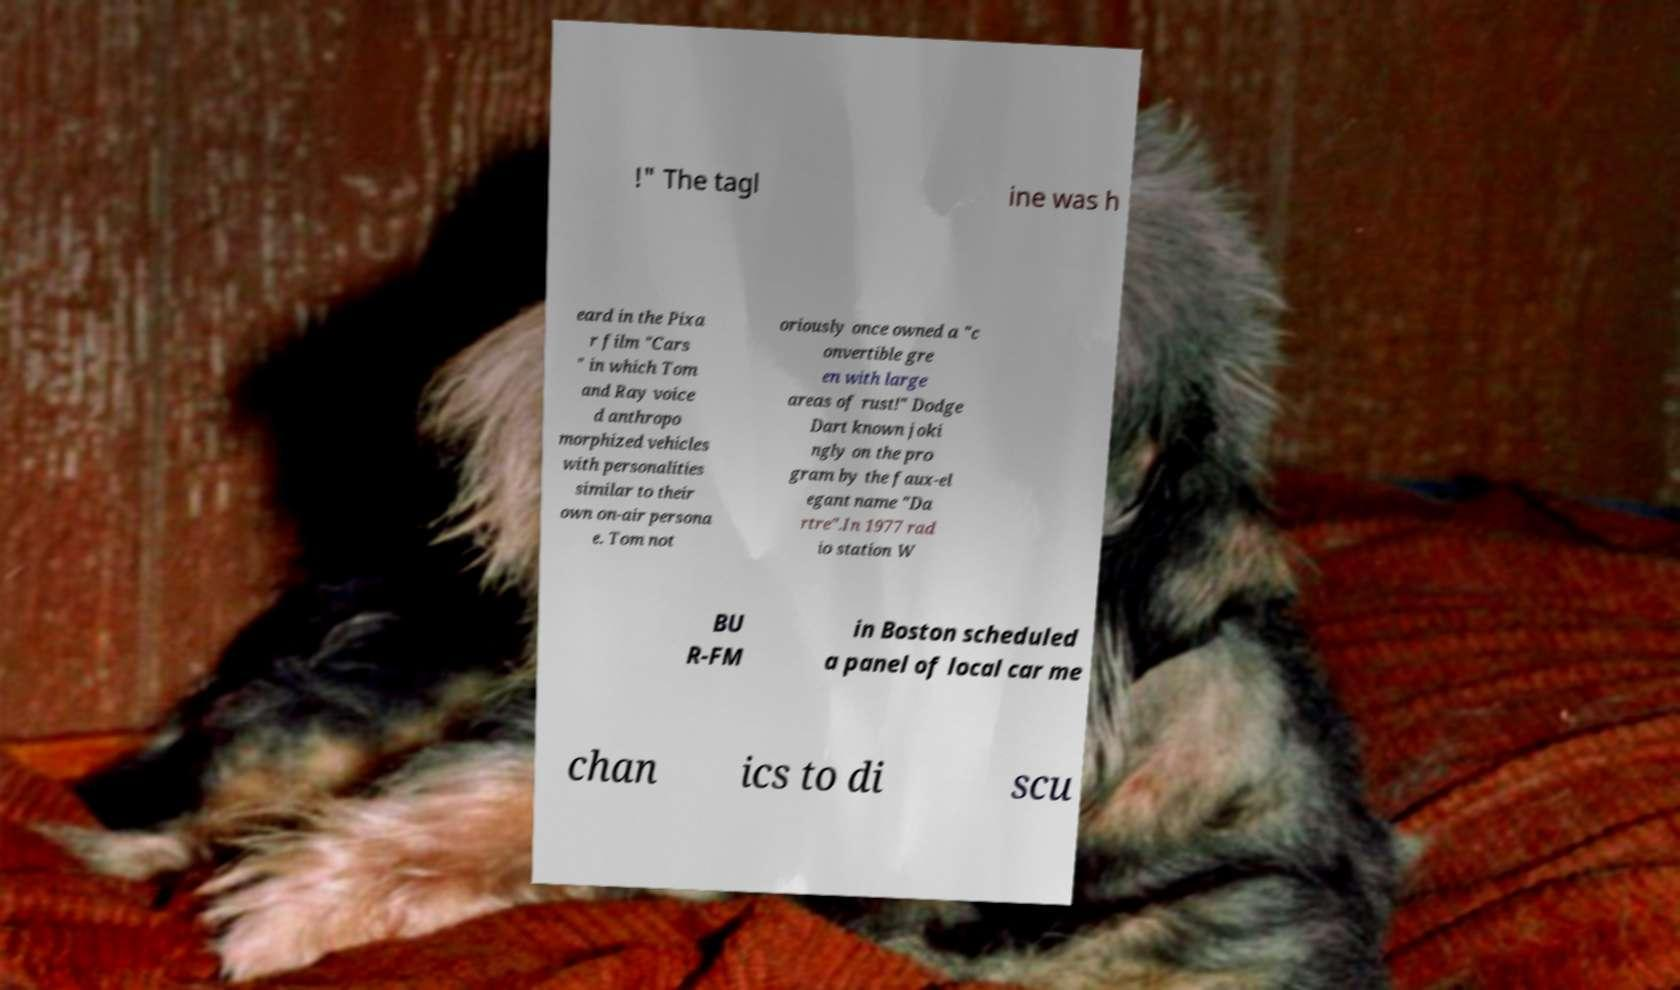What messages or text are displayed in this image? I need them in a readable, typed format. !" The tagl ine was h eard in the Pixa r film "Cars " in which Tom and Ray voice d anthropo morphized vehicles with personalities similar to their own on-air persona e. Tom not oriously once owned a "c onvertible gre en with large areas of rust!" Dodge Dart known joki ngly on the pro gram by the faux-el egant name "Da rtre".In 1977 rad io station W BU R-FM in Boston scheduled a panel of local car me chan ics to di scu 